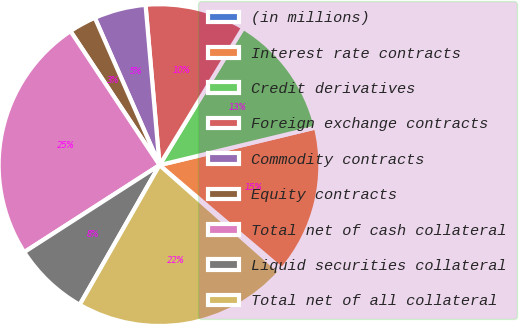Convert chart to OTSL. <chart><loc_0><loc_0><loc_500><loc_500><pie_chart><fcel>(in millions)<fcel>Interest rate contracts<fcel>Credit derivatives<fcel>Foreign exchange contracts<fcel>Commodity contracts<fcel>Equity contracts<fcel>Total net of cash collateral<fcel>Liquid securities collateral<fcel>Total net of all collateral<nl><fcel>0.31%<fcel>14.98%<fcel>12.53%<fcel>10.09%<fcel>5.2%<fcel>2.75%<fcel>24.76%<fcel>7.64%<fcel>21.74%<nl></chart> 